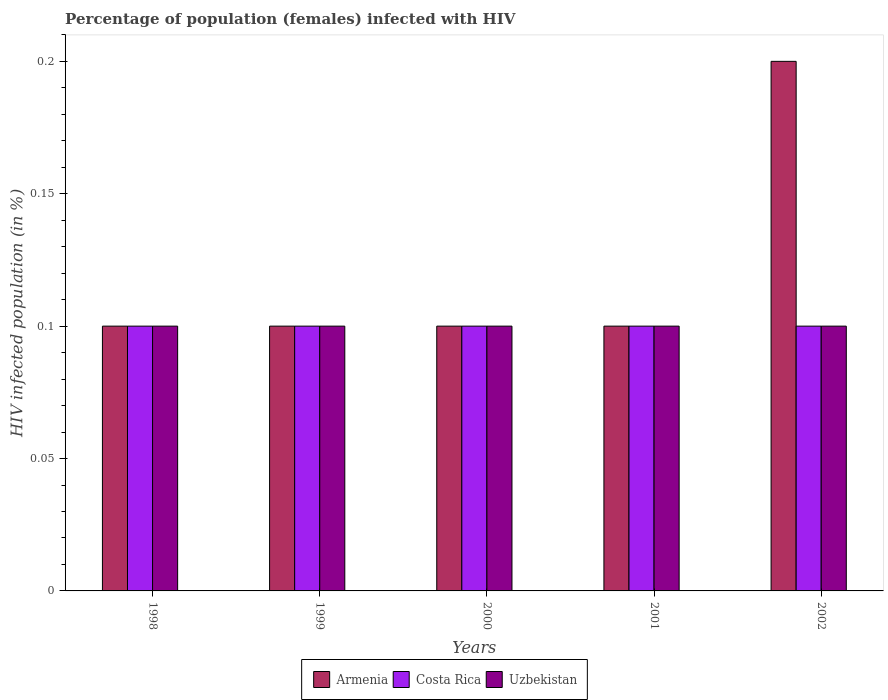Are the number of bars per tick equal to the number of legend labels?
Ensure brevity in your answer.  Yes. How many bars are there on the 5th tick from the right?
Your answer should be very brief. 3. Across all years, what is the maximum percentage of HIV infected female population in Costa Rica?
Your answer should be compact. 0.1. Across all years, what is the minimum percentage of HIV infected female population in Uzbekistan?
Provide a succinct answer. 0.1. In which year was the percentage of HIV infected female population in Costa Rica minimum?
Provide a short and direct response. 1998. What is the total percentage of HIV infected female population in Costa Rica in the graph?
Provide a succinct answer. 0.5. What is the difference between the percentage of HIV infected female population in Uzbekistan in 1999 and that in 2001?
Your answer should be compact. 0. In the year 2001, what is the difference between the percentage of HIV infected female population in Armenia and percentage of HIV infected female population in Uzbekistan?
Your answer should be very brief. 0. Is the difference between the percentage of HIV infected female population in Armenia in 2000 and 2001 greater than the difference between the percentage of HIV infected female population in Uzbekistan in 2000 and 2001?
Your answer should be compact. No. What is the difference between the highest and the second highest percentage of HIV infected female population in Uzbekistan?
Keep it short and to the point. 0. What is the difference between the highest and the lowest percentage of HIV infected female population in Costa Rica?
Offer a very short reply. 0. In how many years, is the percentage of HIV infected female population in Armenia greater than the average percentage of HIV infected female population in Armenia taken over all years?
Your answer should be very brief. 1. What does the 1st bar from the left in 1999 represents?
Provide a short and direct response. Armenia. How many bars are there?
Provide a short and direct response. 15. Are all the bars in the graph horizontal?
Provide a short and direct response. No. How many years are there in the graph?
Provide a short and direct response. 5. What is the difference between two consecutive major ticks on the Y-axis?
Offer a terse response. 0.05. Where does the legend appear in the graph?
Provide a short and direct response. Bottom center. How are the legend labels stacked?
Your answer should be compact. Horizontal. What is the title of the graph?
Provide a short and direct response. Percentage of population (females) infected with HIV. Does "Burundi" appear as one of the legend labels in the graph?
Your response must be concise. No. What is the label or title of the Y-axis?
Keep it short and to the point. HIV infected population (in %). What is the HIV infected population (in %) in Armenia in 1999?
Your answer should be very brief. 0.1. What is the HIV infected population (in %) in Costa Rica in 1999?
Provide a succinct answer. 0.1. What is the HIV infected population (in %) of Costa Rica in 2000?
Provide a short and direct response. 0.1. What is the HIV infected population (in %) in Uzbekistan in 2000?
Keep it short and to the point. 0.1. What is the HIV infected population (in %) in Armenia in 2001?
Your answer should be very brief. 0.1. What is the HIV infected population (in %) of Armenia in 2002?
Offer a terse response. 0.2. What is the HIV infected population (in %) of Costa Rica in 2002?
Make the answer very short. 0.1. Across all years, what is the maximum HIV infected population (in %) of Armenia?
Ensure brevity in your answer.  0.2. Across all years, what is the maximum HIV infected population (in %) of Costa Rica?
Your answer should be very brief. 0.1. Across all years, what is the minimum HIV infected population (in %) in Armenia?
Ensure brevity in your answer.  0.1. Across all years, what is the minimum HIV infected population (in %) in Costa Rica?
Ensure brevity in your answer.  0.1. What is the total HIV infected population (in %) in Costa Rica in the graph?
Make the answer very short. 0.5. What is the total HIV infected population (in %) in Uzbekistan in the graph?
Ensure brevity in your answer.  0.5. What is the difference between the HIV infected population (in %) in Armenia in 1998 and that in 1999?
Give a very brief answer. 0. What is the difference between the HIV infected population (in %) in Costa Rica in 1998 and that in 1999?
Provide a short and direct response. 0. What is the difference between the HIV infected population (in %) in Uzbekistan in 1998 and that in 1999?
Your answer should be very brief. 0. What is the difference between the HIV infected population (in %) in Costa Rica in 1998 and that in 2000?
Offer a very short reply. 0. What is the difference between the HIV infected population (in %) in Uzbekistan in 1998 and that in 2001?
Offer a very short reply. 0. What is the difference between the HIV infected population (in %) of Costa Rica in 1998 and that in 2002?
Offer a very short reply. 0. What is the difference between the HIV infected population (in %) of Costa Rica in 1999 and that in 2001?
Make the answer very short. 0. What is the difference between the HIV infected population (in %) of Uzbekistan in 1999 and that in 2001?
Provide a succinct answer. 0. What is the difference between the HIV infected population (in %) in Costa Rica in 1999 and that in 2002?
Your answer should be compact. 0. What is the difference between the HIV infected population (in %) of Armenia in 2000 and that in 2001?
Provide a succinct answer. 0. What is the difference between the HIV infected population (in %) of Armenia in 2001 and that in 2002?
Your answer should be very brief. -0.1. What is the difference between the HIV infected population (in %) of Costa Rica in 2001 and that in 2002?
Provide a short and direct response. 0. What is the difference between the HIV infected population (in %) in Uzbekistan in 2001 and that in 2002?
Offer a terse response. 0. What is the difference between the HIV infected population (in %) in Armenia in 1998 and the HIV infected population (in %) in Costa Rica in 1999?
Keep it short and to the point. 0. What is the difference between the HIV infected population (in %) of Armenia in 1998 and the HIV infected population (in %) of Uzbekistan in 1999?
Provide a short and direct response. 0. What is the difference between the HIV infected population (in %) in Costa Rica in 1998 and the HIV infected population (in %) in Uzbekistan in 1999?
Your response must be concise. 0. What is the difference between the HIV infected population (in %) in Armenia in 1998 and the HIV infected population (in %) in Costa Rica in 2000?
Provide a succinct answer. 0. What is the difference between the HIV infected population (in %) in Costa Rica in 1998 and the HIV infected population (in %) in Uzbekistan in 2000?
Your response must be concise. 0. What is the difference between the HIV infected population (in %) in Armenia in 1998 and the HIV infected population (in %) in Costa Rica in 2001?
Provide a succinct answer. 0. What is the difference between the HIV infected population (in %) in Armenia in 1998 and the HIV infected population (in %) in Uzbekistan in 2001?
Your answer should be compact. 0. What is the difference between the HIV infected population (in %) of Armenia in 1998 and the HIV infected population (in %) of Costa Rica in 2002?
Your answer should be very brief. 0. What is the difference between the HIV infected population (in %) in Armenia in 1999 and the HIV infected population (in %) in Costa Rica in 2000?
Give a very brief answer. 0. What is the difference between the HIV infected population (in %) of Armenia in 1999 and the HIV infected population (in %) of Costa Rica in 2001?
Make the answer very short. 0. What is the difference between the HIV infected population (in %) of Costa Rica in 1999 and the HIV infected population (in %) of Uzbekistan in 2001?
Offer a terse response. 0. What is the difference between the HIV infected population (in %) of Armenia in 1999 and the HIV infected population (in %) of Costa Rica in 2002?
Your answer should be compact. 0. What is the difference between the HIV infected population (in %) in Armenia in 2000 and the HIV infected population (in %) in Costa Rica in 2001?
Make the answer very short. 0. What is the difference between the HIV infected population (in %) in Armenia in 2000 and the HIV infected population (in %) in Uzbekistan in 2002?
Your answer should be very brief. 0. What is the difference between the HIV infected population (in %) of Costa Rica in 2000 and the HIV infected population (in %) of Uzbekistan in 2002?
Ensure brevity in your answer.  0. What is the difference between the HIV infected population (in %) in Armenia in 2001 and the HIV infected population (in %) in Uzbekistan in 2002?
Give a very brief answer. 0. What is the average HIV infected population (in %) in Armenia per year?
Your answer should be very brief. 0.12. In the year 1999, what is the difference between the HIV infected population (in %) of Armenia and HIV infected population (in %) of Costa Rica?
Ensure brevity in your answer.  0. In the year 1999, what is the difference between the HIV infected population (in %) of Armenia and HIV infected population (in %) of Uzbekistan?
Offer a terse response. 0. In the year 1999, what is the difference between the HIV infected population (in %) in Costa Rica and HIV infected population (in %) in Uzbekistan?
Ensure brevity in your answer.  0. In the year 2000, what is the difference between the HIV infected population (in %) in Armenia and HIV infected population (in %) in Uzbekistan?
Your response must be concise. 0. In the year 2002, what is the difference between the HIV infected population (in %) in Armenia and HIV infected population (in %) in Costa Rica?
Provide a short and direct response. 0.1. In the year 2002, what is the difference between the HIV infected population (in %) of Armenia and HIV infected population (in %) of Uzbekistan?
Offer a terse response. 0.1. In the year 2002, what is the difference between the HIV infected population (in %) of Costa Rica and HIV infected population (in %) of Uzbekistan?
Your answer should be compact. 0. What is the ratio of the HIV infected population (in %) of Costa Rica in 1998 to that in 1999?
Make the answer very short. 1. What is the ratio of the HIV infected population (in %) in Uzbekistan in 1998 to that in 1999?
Give a very brief answer. 1. What is the ratio of the HIV infected population (in %) of Costa Rica in 1998 to that in 2000?
Offer a terse response. 1. What is the ratio of the HIV infected population (in %) of Uzbekistan in 1998 to that in 2000?
Your answer should be very brief. 1. What is the ratio of the HIV infected population (in %) in Armenia in 1998 to that in 2001?
Provide a succinct answer. 1. What is the ratio of the HIV infected population (in %) of Uzbekistan in 1998 to that in 2001?
Provide a succinct answer. 1. What is the ratio of the HIV infected population (in %) in Armenia in 1998 to that in 2002?
Your response must be concise. 0.5. What is the ratio of the HIV infected population (in %) in Armenia in 1999 to that in 2001?
Keep it short and to the point. 1. What is the ratio of the HIV infected population (in %) of Costa Rica in 1999 to that in 2001?
Make the answer very short. 1. What is the ratio of the HIV infected population (in %) in Uzbekistan in 1999 to that in 2001?
Provide a succinct answer. 1. What is the ratio of the HIV infected population (in %) of Armenia in 1999 to that in 2002?
Give a very brief answer. 0.5. What is the ratio of the HIV infected population (in %) of Uzbekistan in 1999 to that in 2002?
Offer a terse response. 1. What is the ratio of the HIV infected population (in %) of Armenia in 2000 to that in 2001?
Ensure brevity in your answer.  1. What is the ratio of the HIV infected population (in %) in Costa Rica in 2000 to that in 2001?
Provide a succinct answer. 1. What is the ratio of the HIV infected population (in %) of Uzbekistan in 2000 to that in 2001?
Provide a succinct answer. 1. What is the ratio of the HIV infected population (in %) of Armenia in 2000 to that in 2002?
Your response must be concise. 0.5. What is the ratio of the HIV infected population (in %) of Armenia in 2001 to that in 2002?
Keep it short and to the point. 0.5. What is the ratio of the HIV infected population (in %) of Uzbekistan in 2001 to that in 2002?
Provide a succinct answer. 1. What is the difference between the highest and the second highest HIV infected population (in %) in Costa Rica?
Your answer should be very brief. 0. What is the difference between the highest and the second highest HIV infected population (in %) of Uzbekistan?
Keep it short and to the point. 0. What is the difference between the highest and the lowest HIV infected population (in %) of Costa Rica?
Ensure brevity in your answer.  0. What is the difference between the highest and the lowest HIV infected population (in %) of Uzbekistan?
Give a very brief answer. 0. 